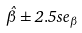<formula> <loc_0><loc_0><loc_500><loc_500>\hat { \beta } \pm 2 . 5 s e _ { \beta }</formula> 